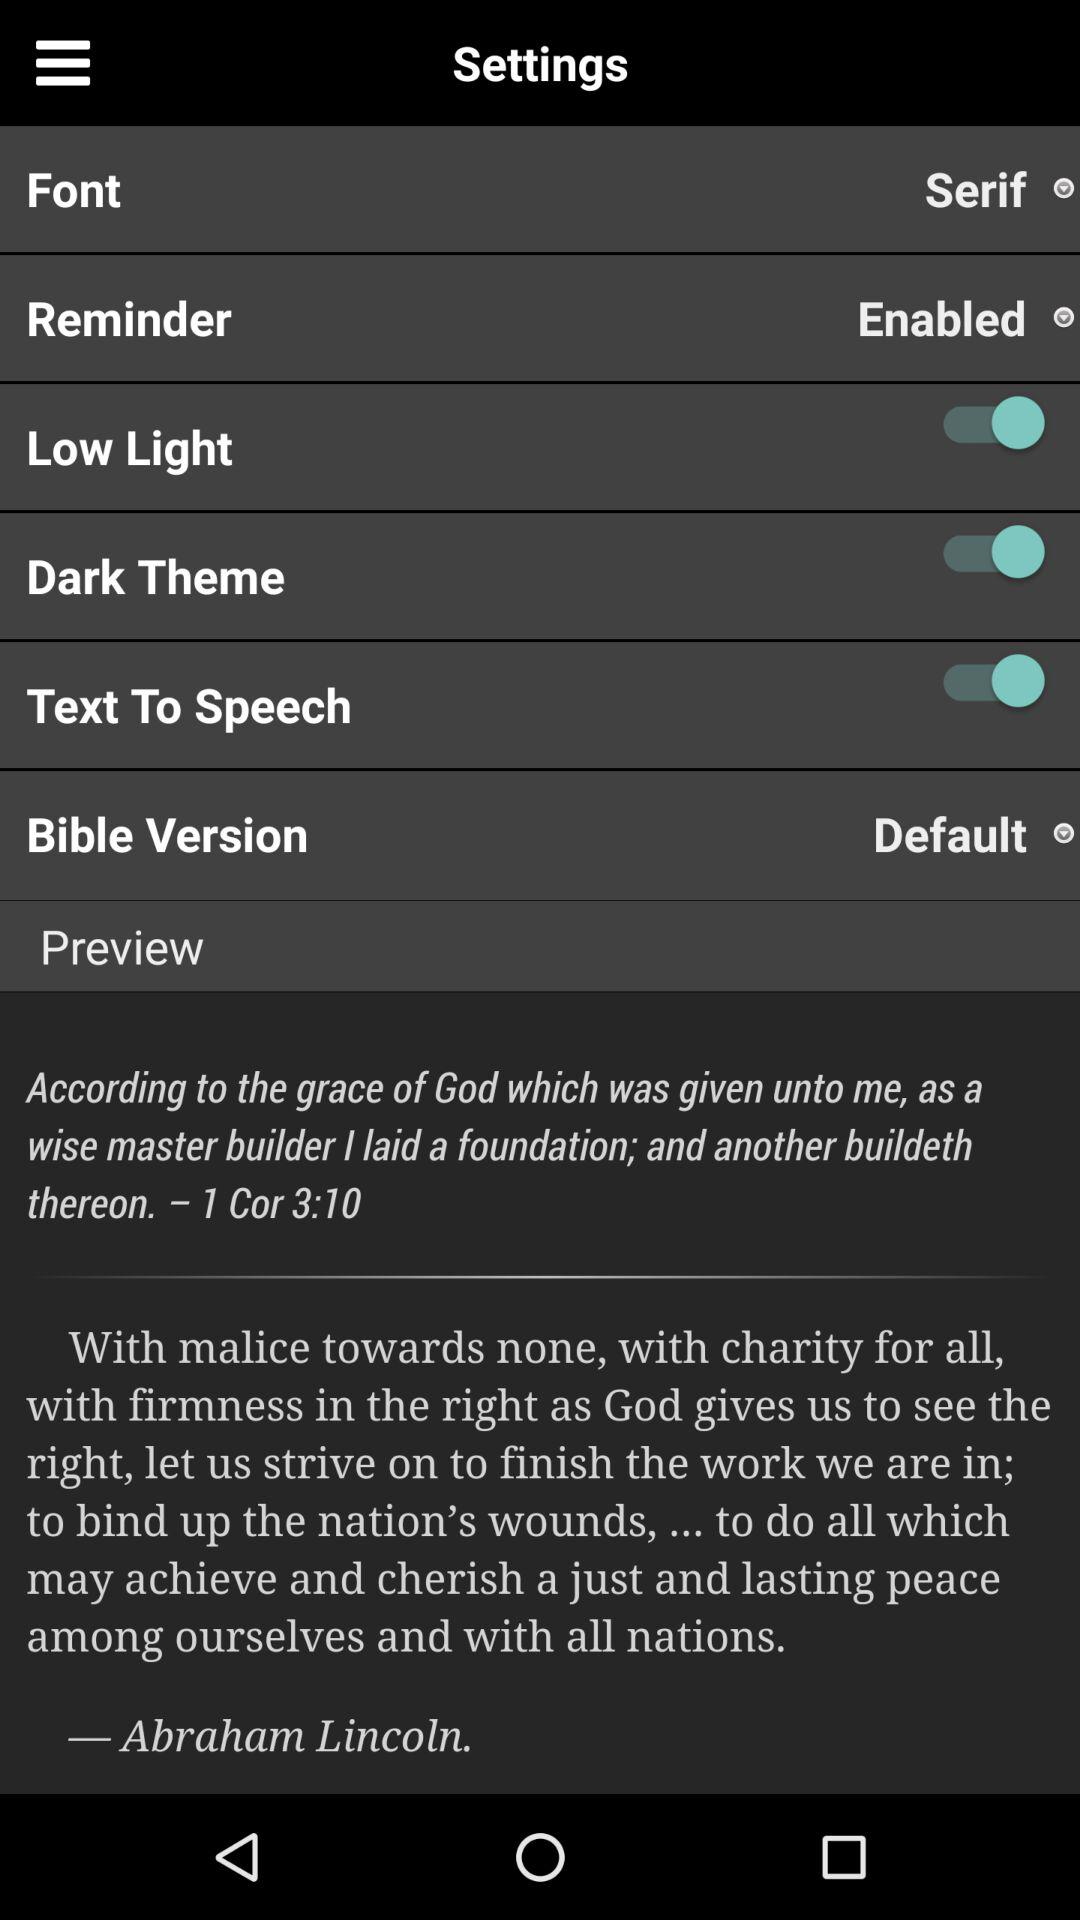What is the status of the Dark theme? The status is on. 